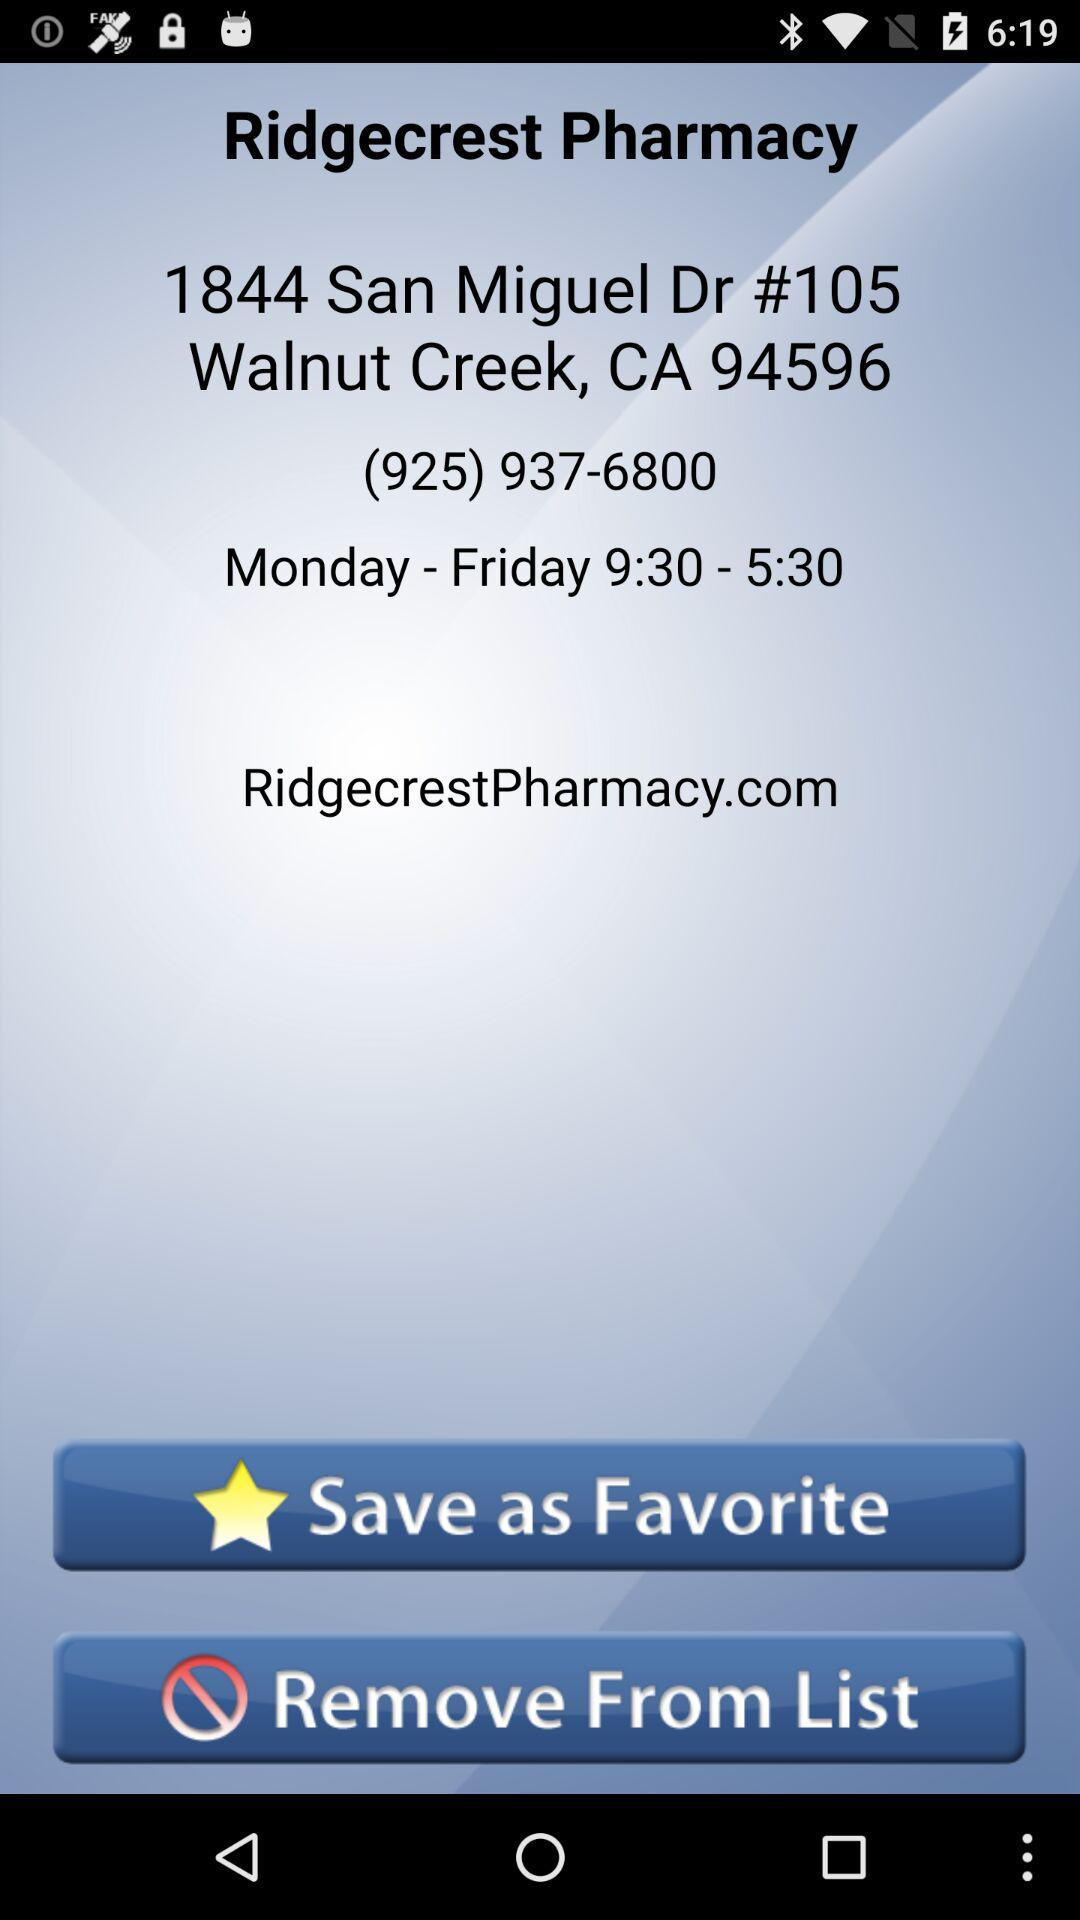What are the days mentioned for visiting "Ridgecrest Pharmacy"? The mentioned days are from Monday to Friday. 